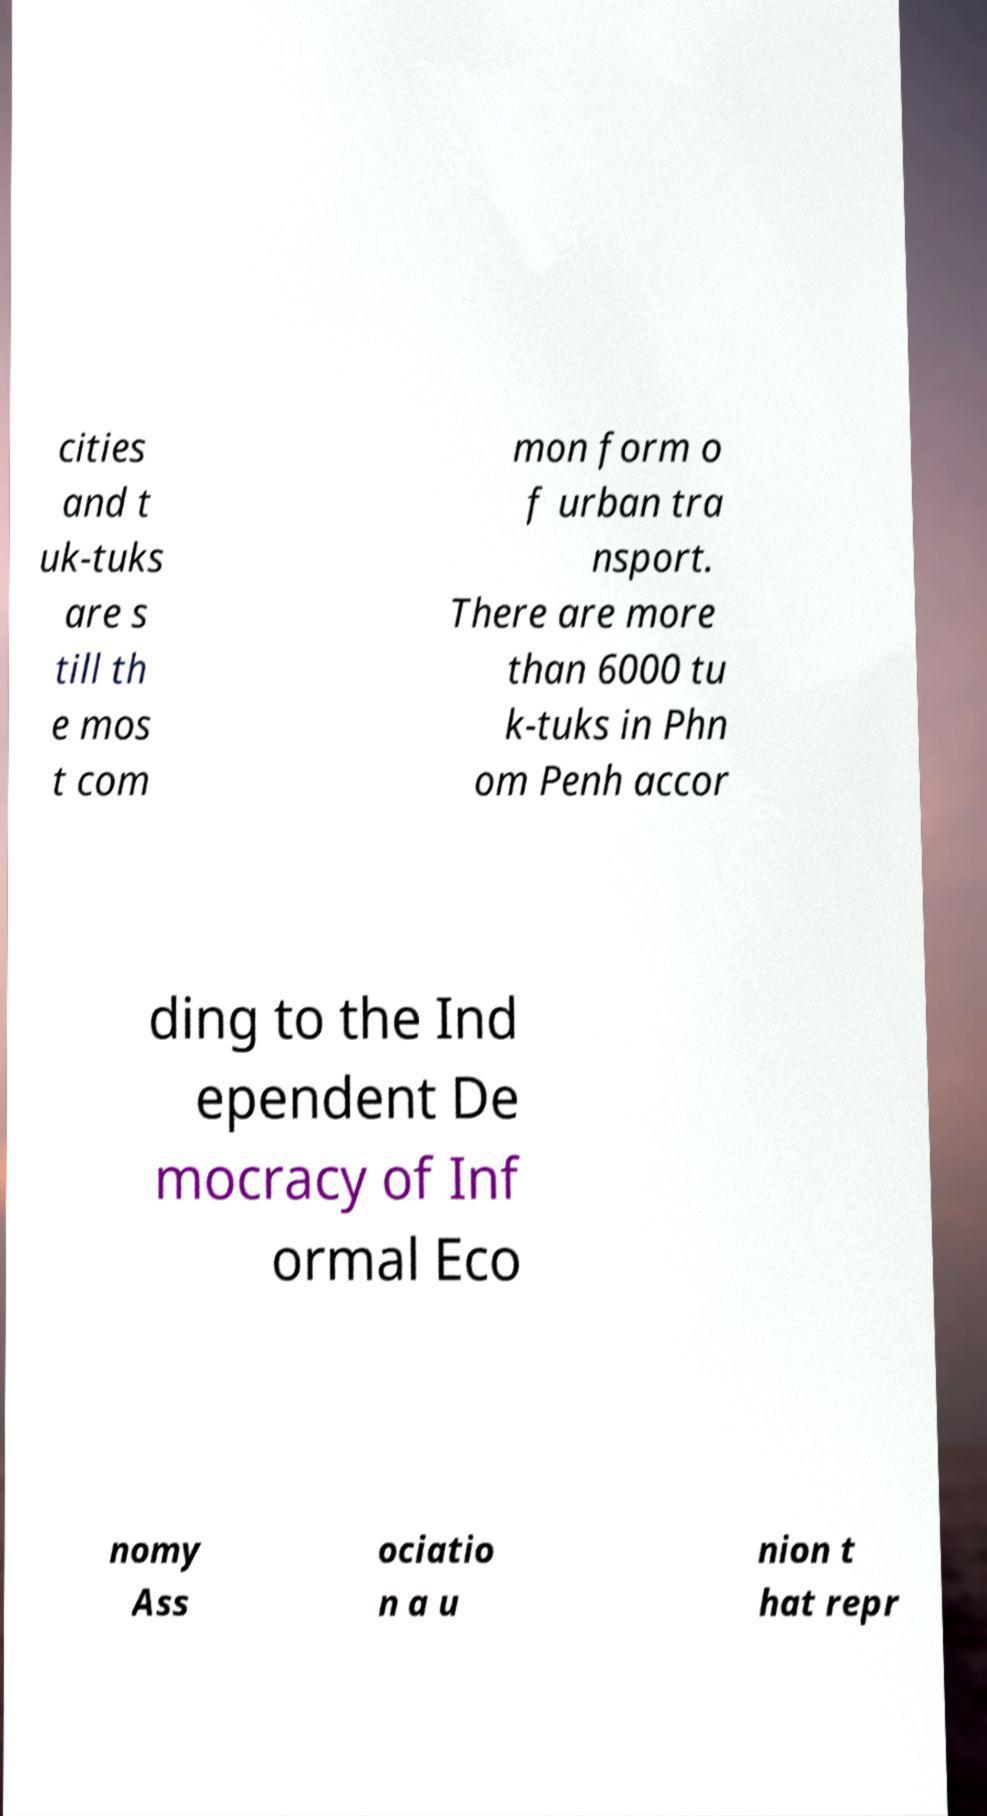Can you accurately transcribe the text from the provided image for me? cities and t uk-tuks are s till th e mos t com mon form o f urban tra nsport. There are more than 6000 tu k-tuks in Phn om Penh accor ding to the Ind ependent De mocracy of Inf ormal Eco nomy Ass ociatio n a u nion t hat repr 